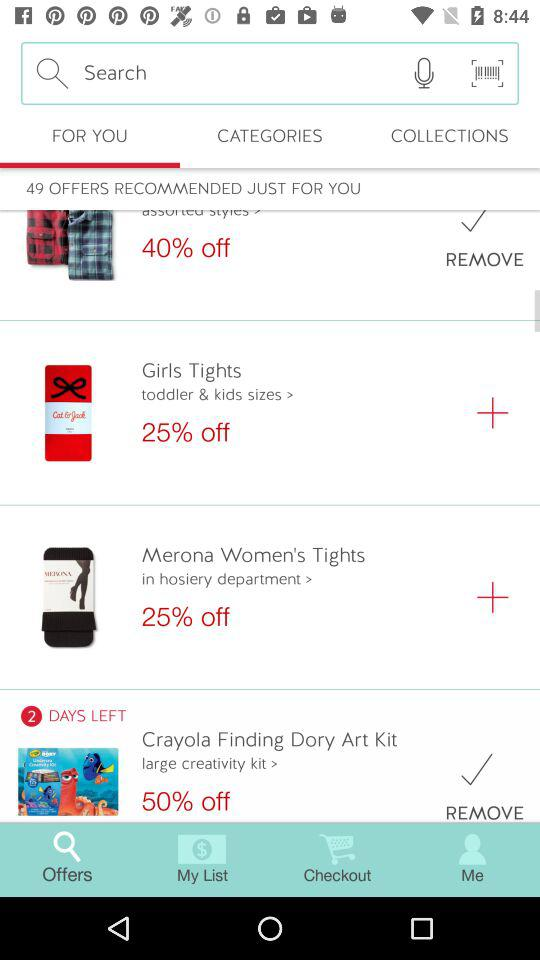How much of a discount is on "Girls Tights"? The discount is 25% off on "Girls Tights". 